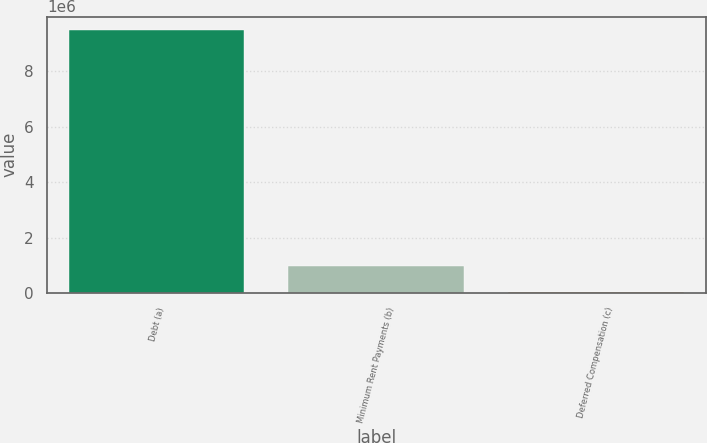Convert chart to OTSL. <chart><loc_0><loc_0><loc_500><loc_500><bar_chart><fcel>Debt (a)<fcel>Minimum Rent Payments (b)<fcel>Deferred Compensation (c)<nl><fcel>9.50873e+06<fcel>969456<fcel>20647<nl></chart> 